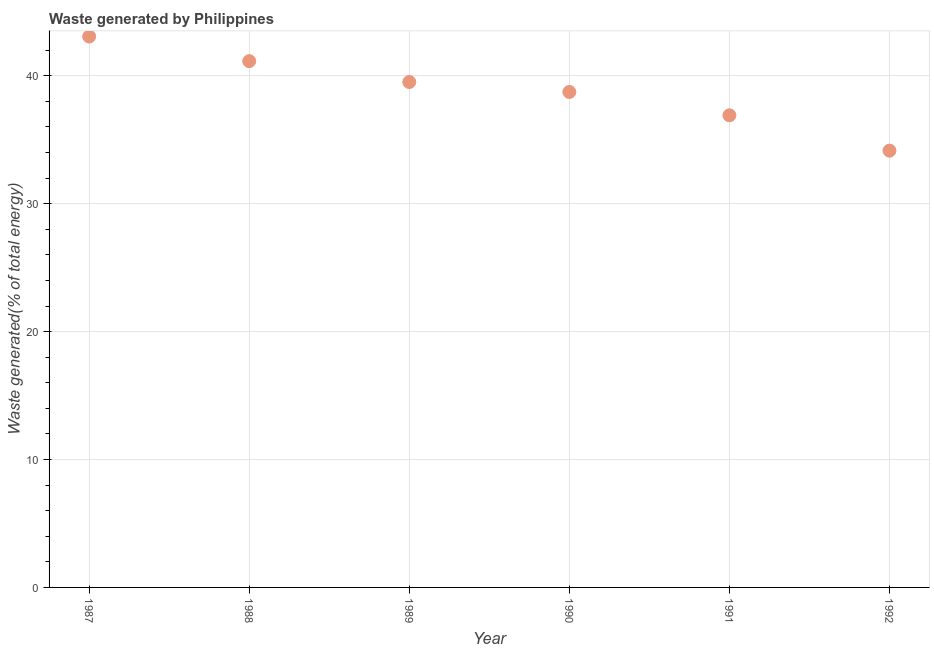What is the amount of waste generated in 1987?
Make the answer very short. 43.07. Across all years, what is the maximum amount of waste generated?
Your answer should be very brief. 43.07. Across all years, what is the minimum amount of waste generated?
Provide a succinct answer. 34.15. In which year was the amount of waste generated minimum?
Make the answer very short. 1992. What is the sum of the amount of waste generated?
Your answer should be very brief. 233.52. What is the difference between the amount of waste generated in 1989 and 1990?
Ensure brevity in your answer.  0.78. What is the average amount of waste generated per year?
Provide a succinct answer. 38.92. What is the median amount of waste generated?
Provide a succinct answer. 39.13. What is the ratio of the amount of waste generated in 1989 to that in 1990?
Offer a terse response. 1.02. Is the difference between the amount of waste generated in 1990 and 1991 greater than the difference between any two years?
Ensure brevity in your answer.  No. What is the difference between the highest and the second highest amount of waste generated?
Provide a succinct answer. 1.92. Is the sum of the amount of waste generated in 1991 and 1992 greater than the maximum amount of waste generated across all years?
Offer a very short reply. Yes. What is the difference between the highest and the lowest amount of waste generated?
Provide a short and direct response. 8.92. In how many years, is the amount of waste generated greater than the average amount of waste generated taken over all years?
Make the answer very short. 3. Does the amount of waste generated monotonically increase over the years?
Your response must be concise. No. How many dotlines are there?
Make the answer very short. 1. Are the values on the major ticks of Y-axis written in scientific E-notation?
Provide a short and direct response. No. Does the graph contain any zero values?
Give a very brief answer. No. Does the graph contain grids?
Make the answer very short. Yes. What is the title of the graph?
Provide a succinct answer. Waste generated by Philippines. What is the label or title of the Y-axis?
Your answer should be very brief. Waste generated(% of total energy). What is the Waste generated(% of total energy) in 1987?
Offer a terse response. 43.07. What is the Waste generated(% of total energy) in 1988?
Keep it short and to the point. 41.15. What is the Waste generated(% of total energy) in 1989?
Provide a short and direct response. 39.51. What is the Waste generated(% of total energy) in 1990?
Provide a succinct answer. 38.74. What is the Waste generated(% of total energy) in 1991?
Ensure brevity in your answer.  36.91. What is the Waste generated(% of total energy) in 1992?
Keep it short and to the point. 34.15. What is the difference between the Waste generated(% of total energy) in 1987 and 1988?
Make the answer very short. 1.92. What is the difference between the Waste generated(% of total energy) in 1987 and 1989?
Provide a short and direct response. 3.56. What is the difference between the Waste generated(% of total energy) in 1987 and 1990?
Provide a short and direct response. 4.33. What is the difference between the Waste generated(% of total energy) in 1987 and 1991?
Offer a terse response. 6.16. What is the difference between the Waste generated(% of total energy) in 1987 and 1992?
Offer a very short reply. 8.92. What is the difference between the Waste generated(% of total energy) in 1988 and 1989?
Your answer should be compact. 1.63. What is the difference between the Waste generated(% of total energy) in 1988 and 1990?
Offer a terse response. 2.41. What is the difference between the Waste generated(% of total energy) in 1988 and 1991?
Offer a terse response. 4.24. What is the difference between the Waste generated(% of total energy) in 1988 and 1992?
Offer a very short reply. 7. What is the difference between the Waste generated(% of total energy) in 1989 and 1990?
Your response must be concise. 0.78. What is the difference between the Waste generated(% of total energy) in 1989 and 1991?
Your response must be concise. 2.6. What is the difference between the Waste generated(% of total energy) in 1989 and 1992?
Ensure brevity in your answer.  5.37. What is the difference between the Waste generated(% of total energy) in 1990 and 1991?
Your answer should be compact. 1.83. What is the difference between the Waste generated(% of total energy) in 1990 and 1992?
Your answer should be very brief. 4.59. What is the difference between the Waste generated(% of total energy) in 1991 and 1992?
Ensure brevity in your answer.  2.76. What is the ratio of the Waste generated(% of total energy) in 1987 to that in 1988?
Keep it short and to the point. 1.05. What is the ratio of the Waste generated(% of total energy) in 1987 to that in 1989?
Your answer should be very brief. 1.09. What is the ratio of the Waste generated(% of total energy) in 1987 to that in 1990?
Provide a short and direct response. 1.11. What is the ratio of the Waste generated(% of total energy) in 1987 to that in 1991?
Provide a short and direct response. 1.17. What is the ratio of the Waste generated(% of total energy) in 1987 to that in 1992?
Provide a short and direct response. 1.26. What is the ratio of the Waste generated(% of total energy) in 1988 to that in 1989?
Offer a very short reply. 1.04. What is the ratio of the Waste generated(% of total energy) in 1988 to that in 1990?
Your response must be concise. 1.06. What is the ratio of the Waste generated(% of total energy) in 1988 to that in 1991?
Provide a succinct answer. 1.11. What is the ratio of the Waste generated(% of total energy) in 1988 to that in 1992?
Provide a succinct answer. 1.21. What is the ratio of the Waste generated(% of total energy) in 1989 to that in 1991?
Your answer should be compact. 1.07. What is the ratio of the Waste generated(% of total energy) in 1989 to that in 1992?
Give a very brief answer. 1.16. What is the ratio of the Waste generated(% of total energy) in 1990 to that in 1991?
Your response must be concise. 1.05. What is the ratio of the Waste generated(% of total energy) in 1990 to that in 1992?
Your response must be concise. 1.13. What is the ratio of the Waste generated(% of total energy) in 1991 to that in 1992?
Provide a short and direct response. 1.08. 